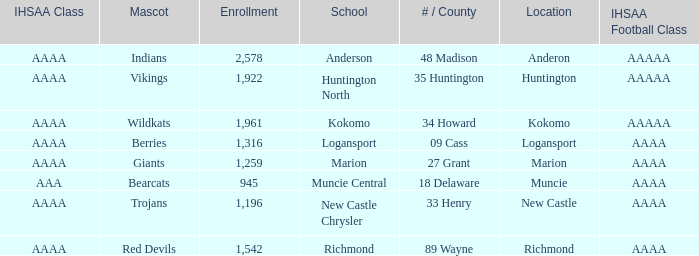What's the least enrolled when the mascot was the Trojans? 1196.0. Parse the full table. {'header': ['IHSAA Class', 'Mascot', 'Enrollment', 'School', '# / County', 'Location', 'IHSAA Football Class'], 'rows': [['AAAA', 'Indians', '2,578', 'Anderson', '48 Madison', 'Anderon', 'AAAAA'], ['AAAA', 'Vikings', '1,922', 'Huntington North', '35 Huntington', 'Huntington', 'AAAAA'], ['AAAA', 'Wildkats', '1,961', 'Kokomo', '34 Howard', 'Kokomo', 'AAAAA'], ['AAAA', 'Berries', '1,316', 'Logansport', '09 Cass', 'Logansport', 'AAAA'], ['AAAA', 'Giants', '1,259', 'Marion', '27 Grant', 'Marion', 'AAAA'], ['AAA', 'Bearcats', '945', 'Muncie Central', '18 Delaware', 'Muncie', 'AAAA'], ['AAAA', 'Trojans', '1,196', 'New Castle Chrysler', '33 Henry', 'New Castle', 'AAAA'], ['AAAA', 'Red Devils', '1,542', 'Richmond', '89 Wayne', 'Richmond', 'AAAA']]} 